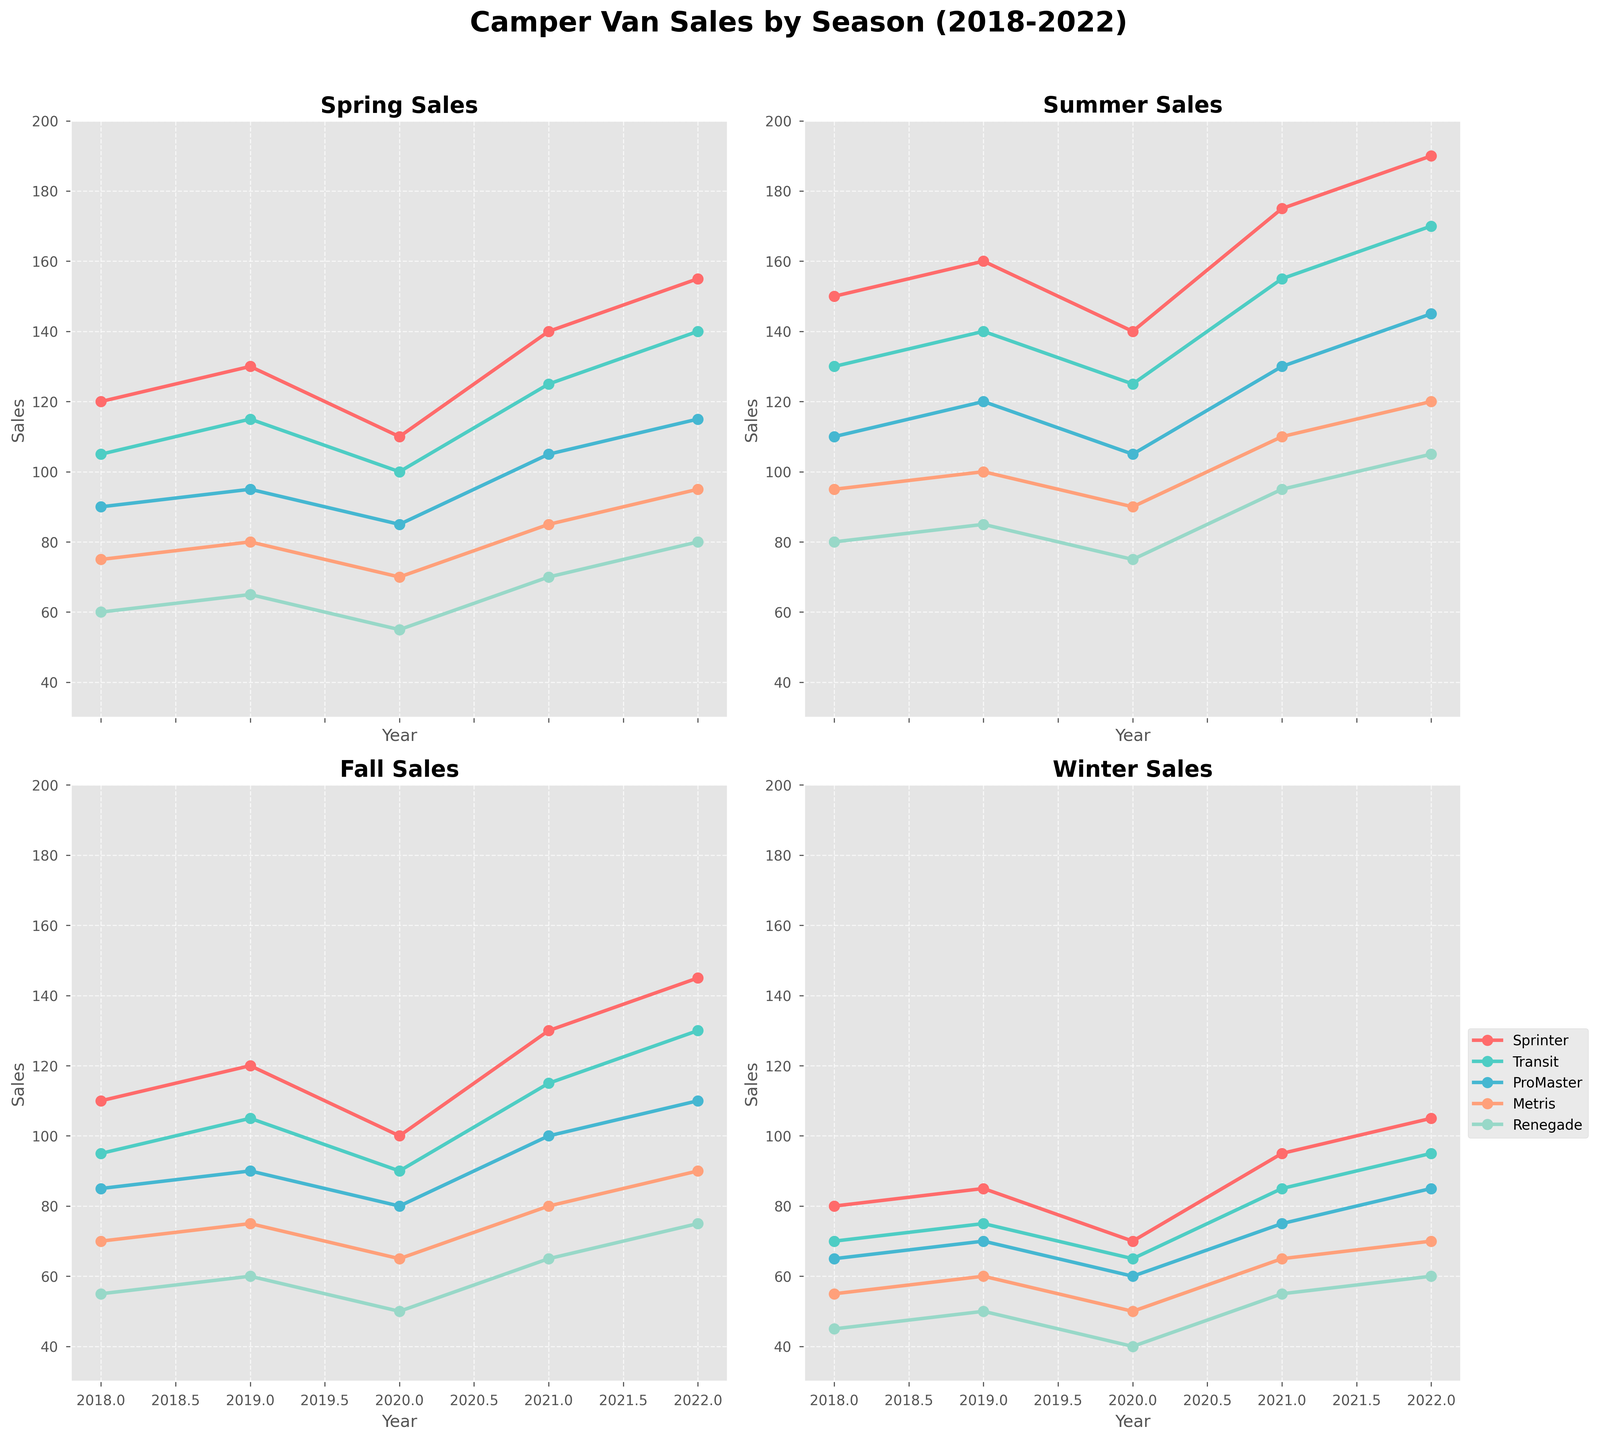What is the title of the figure? The title is displayed at the top of the figure and reads, "Camper Van Sales by Season (2018-2022)".
Answer: Camper Van Sales by Season (2018-2022) How many subplots are there in the figure? The figure is divided into smaller sections, forming a grid with separate plots for each season. By visually dividing the figure, we count 4 subplots.
Answer: 4 Which season appears to have the highest sales for the "Sprinter" model in 2022? By looking at the lines for the "Sprinter" model in each subplot, the highest point in 2022 appears in the subplot titled "Summer Sales".
Answer: Summer How do the "Renegade" sales in Winter 2022 compare to Winter 2018? Compare the value of 2022 in Winter Sales to the value of 2018 in Winter Sales for the "Renegade". The 2022 value is 60 and the 2018 value is 45.
Answer: Higher in 2022 Which model showed the most consistent sales across all seasons and years? By inspecting the plotted lines in all subplots, "Sprinter" shows less fluctuation across years and seasons compared to the other models.
Answer: Sprinter What is the average number of "Metris" camper vans sold in Spring over the 5 years? Collect the sales data for "Metris" in Spring (75, 80, 70, 85, 95), sum them up and divide by 5: (75 + 80 + 70 + 85 + 95) / 5 = 81.
Answer: 81 Which model had the most significant increase in sales from Spring 2021 to Spring 2022? Check the Spring sales for all models from 2021 to 2022, compute the difference for each: 
  - Sprinter: 155-140=15
  - Transit: 140-125=15
  - ProMaster: 115-105=10
  - Metris: 95-85=10
  - Renegade: 80-70=10.
  Sprinter and Transit both have the highest increase of 15 units.
Answer: Sprinter and Transit What was the lowest number of "Transit" camper vans sold in any season/year? Scan the lines for "Transit" in each subplot, the lowest point is in Winter 2020 with a value of 65.
Answer: 65 In which year did the "ProMaster" model have its highest sales during the Fall season? Look for the highest point in "ProMaster" across Fall Sales subplots, which is in 2022 with a value of 110.
Answer: 2022 